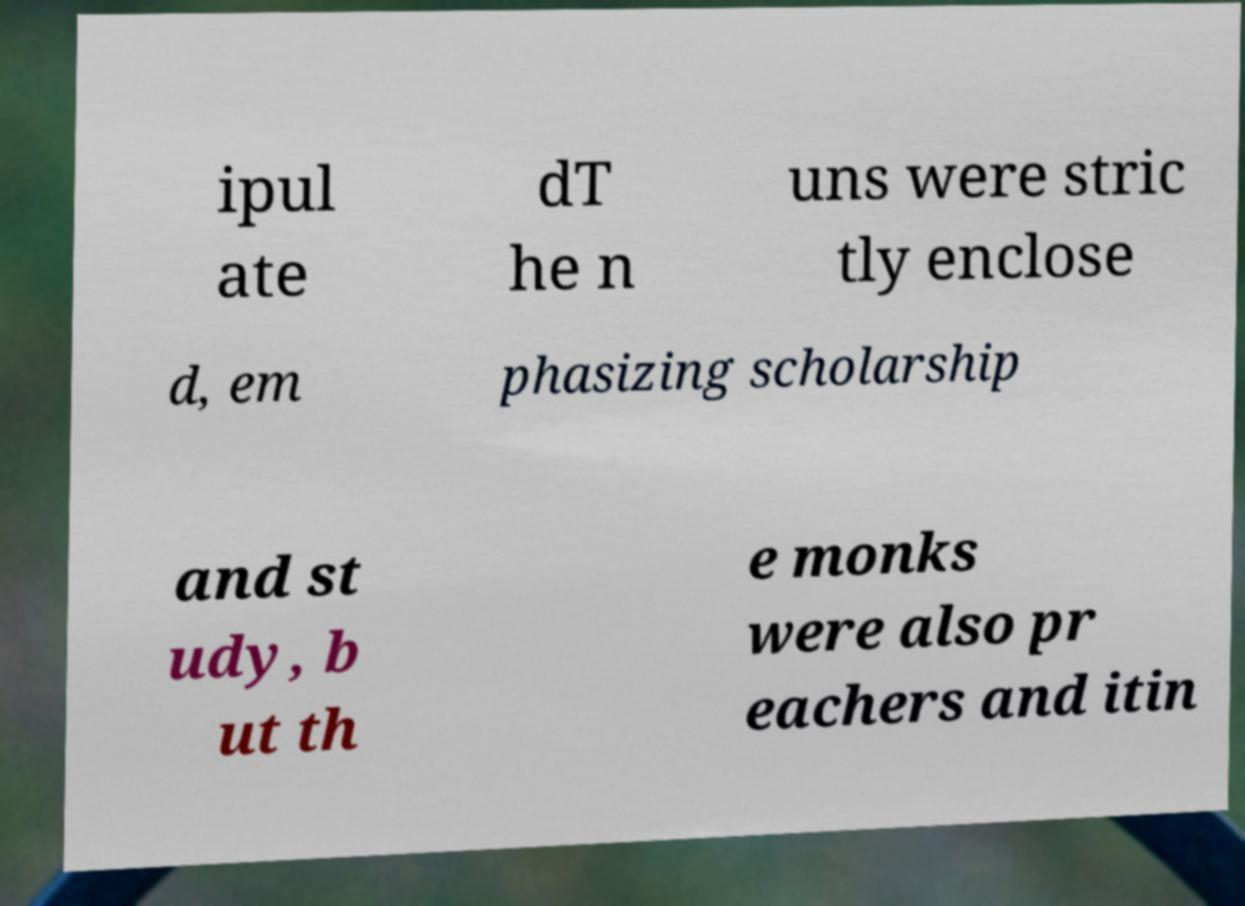I need the written content from this picture converted into text. Can you do that? ipul ate dT he n uns were stric tly enclose d, em phasizing scholarship and st udy, b ut th e monks were also pr eachers and itin 